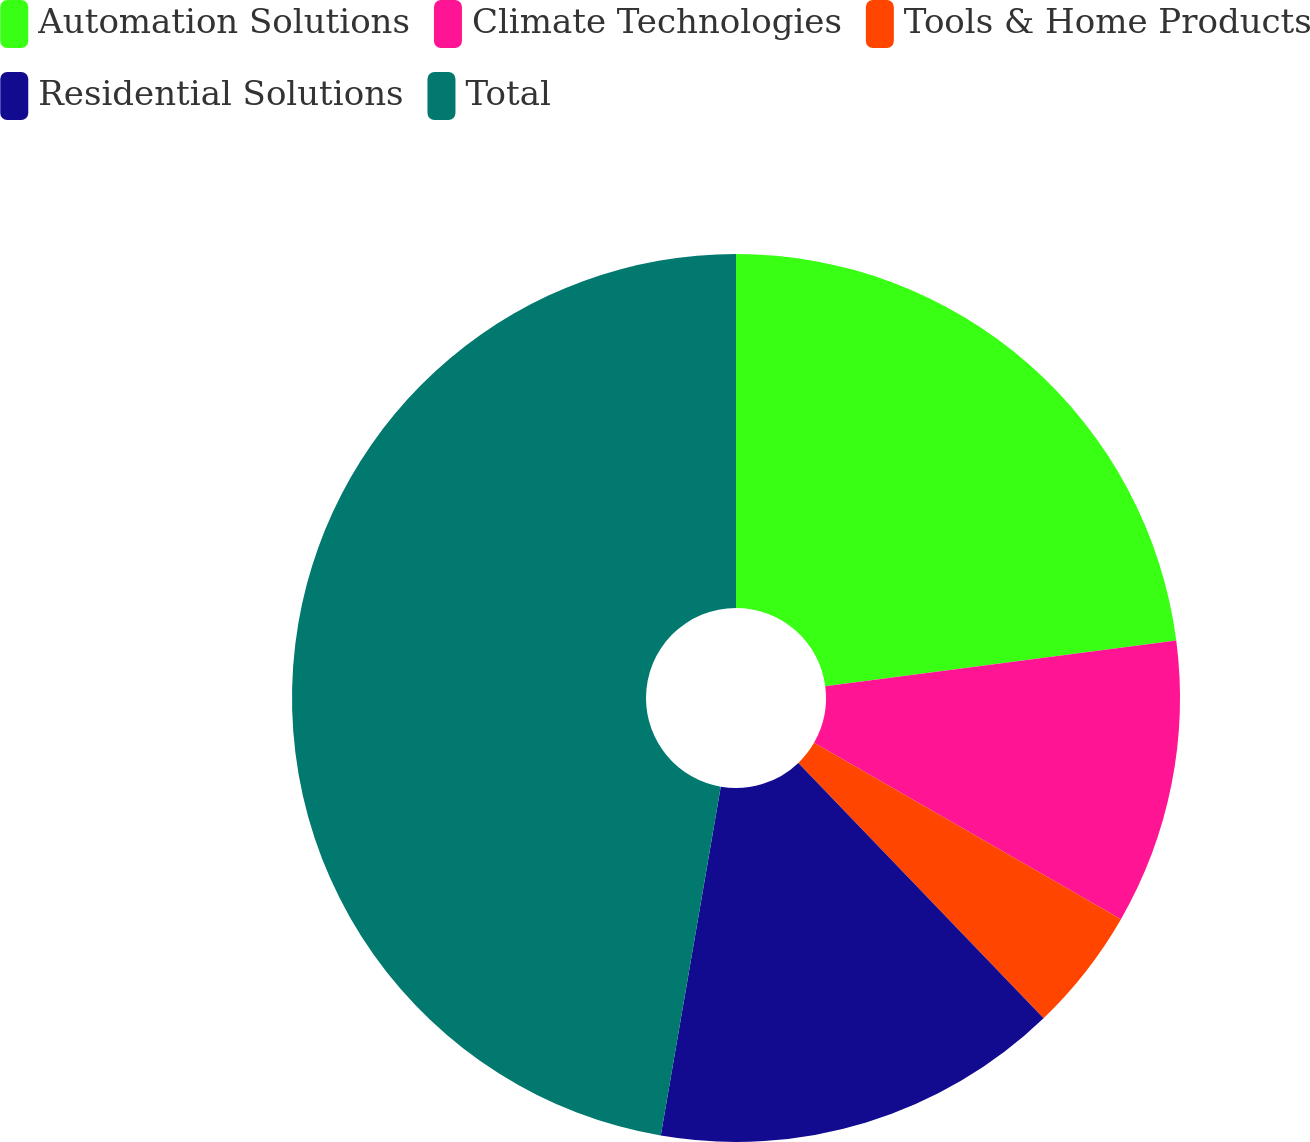<chart> <loc_0><loc_0><loc_500><loc_500><pie_chart><fcel>Automation Solutions<fcel>Climate Technologies<fcel>Tools & Home Products<fcel>Residential Solutions<fcel>Total<nl><fcel>22.93%<fcel>10.37%<fcel>4.52%<fcel>14.89%<fcel>47.29%<nl></chart> 